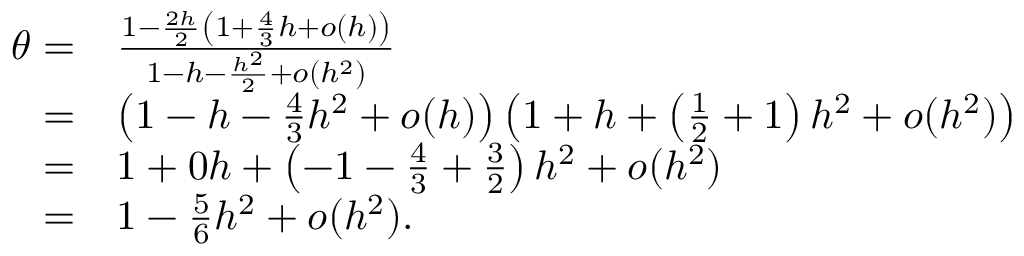Convert formula to latex. <formula><loc_0><loc_0><loc_500><loc_500>\begin{array} { r l } { \theta = } & { \frac { 1 - \frac { 2 h } { 2 } \left ( 1 + \frac { 4 } { 3 } h + o ( h ) \right ) } { 1 - h - \frac { h ^ { 2 } } { 2 } + o ( h ^ { 2 } ) } } \\ { = } & { \left ( 1 - h - \frac { 4 } { 3 } h ^ { 2 } + o ( h ) \right ) \left ( 1 + h + \left ( \frac { 1 } { 2 } + 1 \right ) h ^ { 2 } + o ( h ^ { 2 } ) \right ) } \\ { = } & { 1 + 0 h + \left ( - 1 - \frac { 4 } { 3 } + \frac { 3 } { 2 } \right ) h ^ { 2 } + o ( h ^ { 2 } ) } \\ { = } & { 1 - \frac { 5 } { 6 } h ^ { 2 } + o ( h ^ { 2 } ) . } \end{array}</formula> 